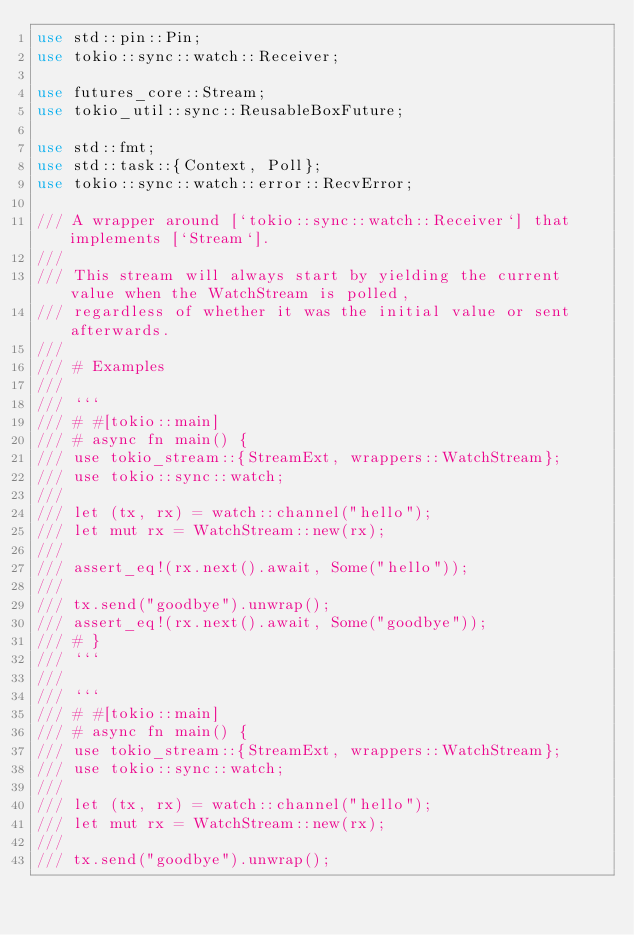Convert code to text. <code><loc_0><loc_0><loc_500><loc_500><_Rust_>use std::pin::Pin;
use tokio::sync::watch::Receiver;

use futures_core::Stream;
use tokio_util::sync::ReusableBoxFuture;

use std::fmt;
use std::task::{Context, Poll};
use tokio::sync::watch::error::RecvError;

/// A wrapper around [`tokio::sync::watch::Receiver`] that implements [`Stream`].
///
/// This stream will always start by yielding the current value when the WatchStream is polled,
/// regardless of whether it was the initial value or sent afterwards.
///
/// # Examples
///
/// ```
/// # #[tokio::main]
/// # async fn main() {
/// use tokio_stream::{StreamExt, wrappers::WatchStream};
/// use tokio::sync::watch;
///
/// let (tx, rx) = watch::channel("hello");
/// let mut rx = WatchStream::new(rx);
///
/// assert_eq!(rx.next().await, Some("hello"));
///
/// tx.send("goodbye").unwrap();
/// assert_eq!(rx.next().await, Some("goodbye"));
/// # }
/// ```
///
/// ```
/// # #[tokio::main]
/// # async fn main() {
/// use tokio_stream::{StreamExt, wrappers::WatchStream};
/// use tokio::sync::watch;
///
/// let (tx, rx) = watch::channel("hello");
/// let mut rx = WatchStream::new(rx);
///
/// tx.send("goodbye").unwrap();</code> 